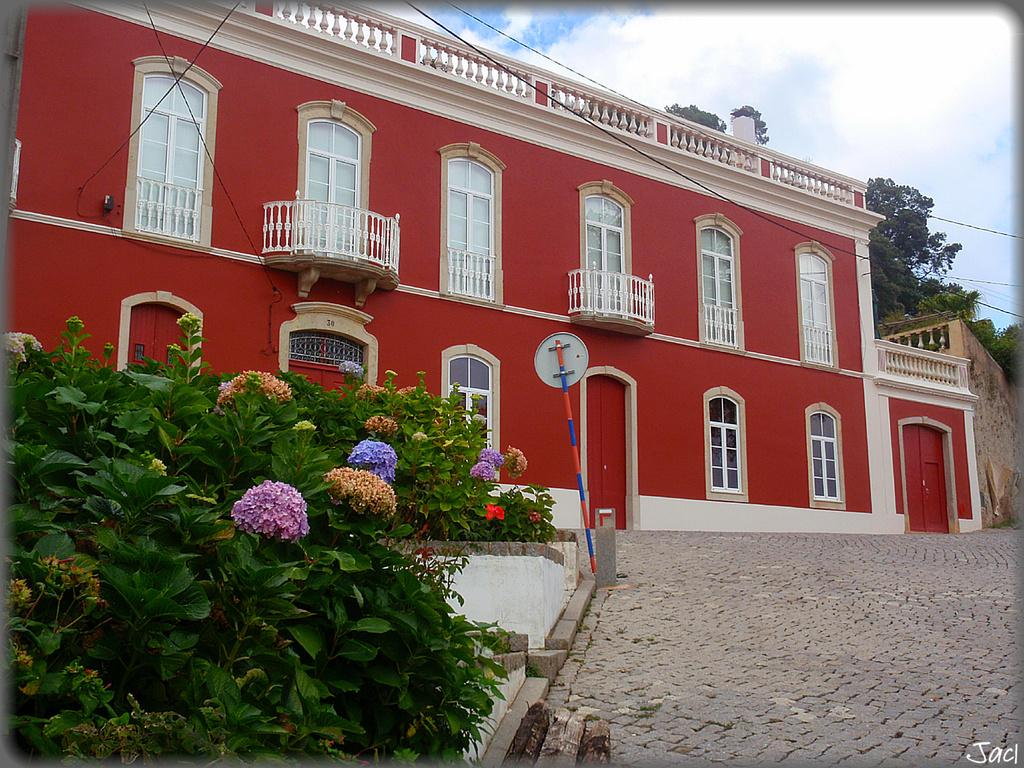What type of structure is visible in the image? There is a building in the image. What type of plants can be seen in the image? There are flower plants in the image. What object is present in the image that might be used for support or signage? There is a pole in the image. What can be seen in the background of the image? There are trees and the sky visible in the background of the image. What type of bells can be heard ringing in the image? There are no bells present in the image, and therefore no sound can be heard. Can you see a worm crawling on the flower plants in the image? There is no worm visible in the image; only flower plants, a building, a pole, trees, and the sky are present. 